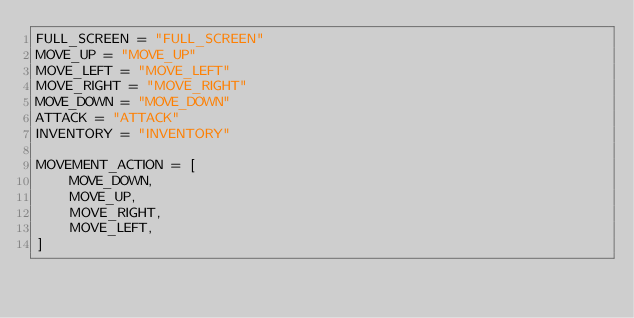<code> <loc_0><loc_0><loc_500><loc_500><_Python_>FULL_SCREEN = "FULL_SCREEN"
MOVE_UP = "MOVE_UP"
MOVE_LEFT = "MOVE_LEFT"
MOVE_RIGHT = "MOVE_RIGHT"
MOVE_DOWN = "MOVE_DOWN"
ATTACK = "ATTACK"
INVENTORY = "INVENTORY"

MOVEMENT_ACTION = [
    MOVE_DOWN,
    MOVE_UP,
    MOVE_RIGHT,
    MOVE_LEFT,
]</code> 